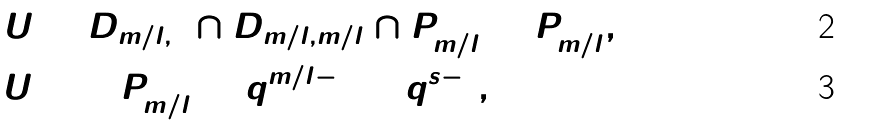Convert formula to latex. <formula><loc_0><loc_0><loc_500><loc_500>U & = D _ { m / l , 1 } \cap D _ { m / l , m / l } \cap P ^ { 0 } _ { m / l } = P ^ { 0 } _ { m / l } , \\ \# U & = \# P ^ { 0 } _ { m / l } = q ^ { m / l - 1 } = q ^ { s - 1 } ,</formula> 